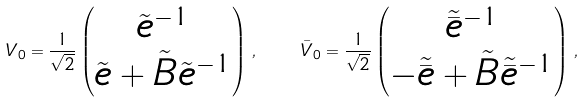<formula> <loc_0><loc_0><loc_500><loc_500>V _ { 0 } = \frac { 1 } { \sqrt { 2 } } \begin{pmatrix} \tilde { e } ^ { - 1 } \\ \tilde { e } + \tilde { B } \tilde { e } ^ { - 1 } \end{pmatrix} \, , \quad \bar { V } _ { 0 } = \frac { 1 } { \sqrt { 2 } } \begin{pmatrix} \tilde { \bar { e } } ^ { - 1 } \\ - \tilde { \bar { e } } + \tilde { B } \tilde { \bar { e } } ^ { - 1 } \end{pmatrix} \, ,</formula> 